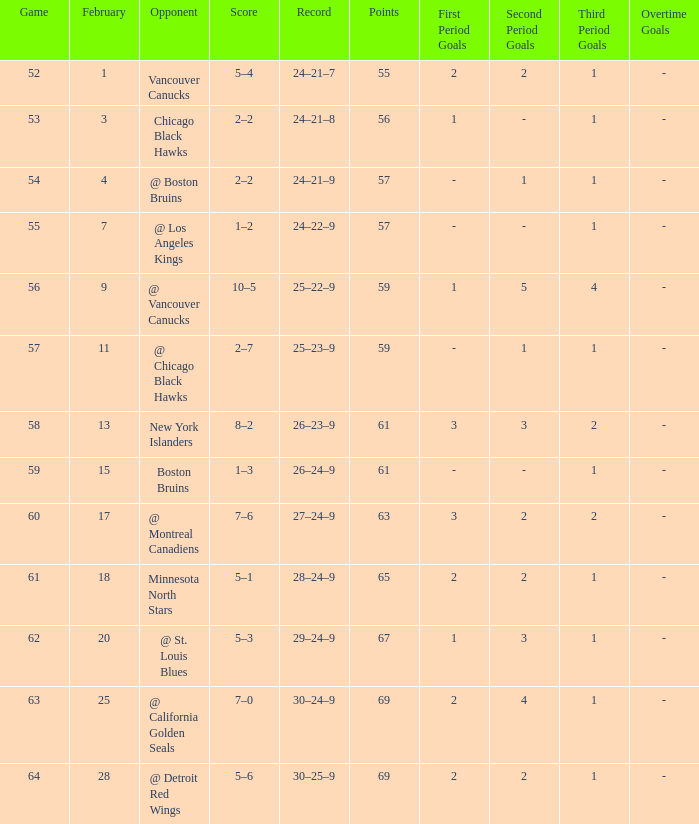How many february games had a record of 29–24–9? 20.0. 